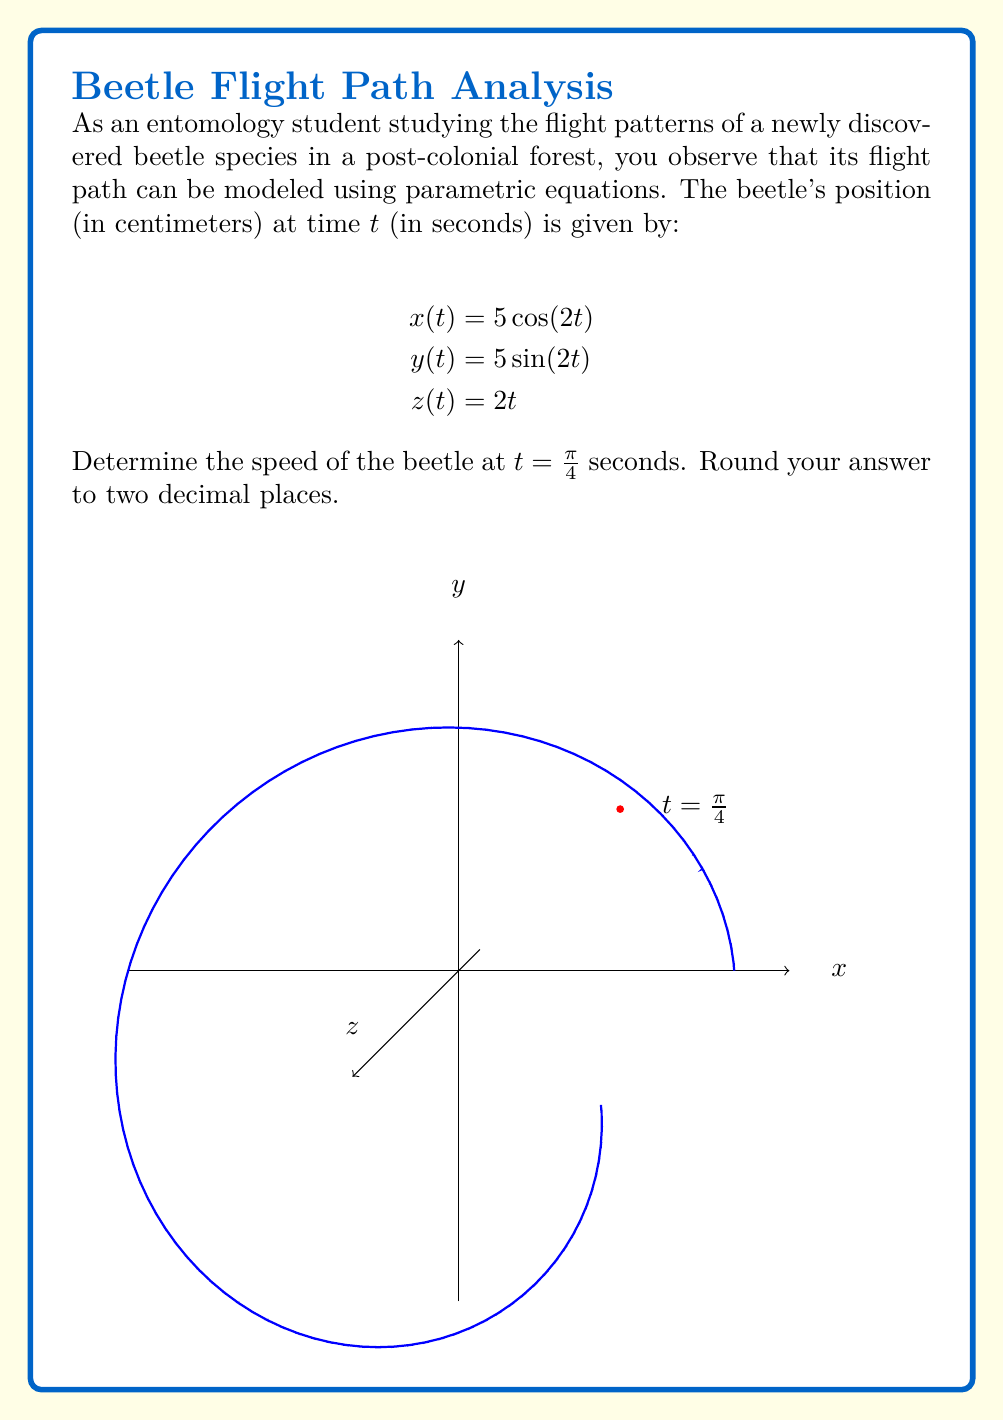Could you help me with this problem? To find the speed of the beetle, we need to calculate the magnitude of its velocity vector at t = π/4. Let's approach this step-by-step:

1) First, we need to find the velocity components by differentiating x(t), y(t), and z(t) with respect to t:

   $$\frac{dx}{dt} = -10\sin(2t)$$
   $$\frac{dy}{dt} = 10\cos(2t)$$
   $$\frac{dz}{dt} = 2$$

2) The velocity vector at any time t is:

   $$\vec{v}(t) = \left(-10\sin(2t), 10\cos(2t), 2\right)$$

3) The speed is the magnitude of the velocity vector:

   $$\text{speed} = \sqrt{\left(\frac{dx}{dt}\right)^2 + \left(\frac{dy}{dt}\right)^2 + \left(\frac{dz}{dt}\right)^2}$$

4) Substituting t = π/4 into our velocity components:

   $$\frac{dx}{dt}\bigg|_{t=\pi/4} = -10\sin(\pi/2) = -10$$
   $$\frac{dy}{dt}\bigg|_{t=\pi/4} = 10\cos(\pi/2) = 0$$
   $$\frac{dz}{dt}\bigg|_{t=\pi/4} = 2$$

5) Now, let's calculate the speed:

   $$\text{speed} = \sqrt{(-10)^2 + 0^2 + 2^2}$$
   $$= \sqrt{100 + 0 + 4}$$
   $$= \sqrt{104}$$
   $$\approx 10.20$$ (rounded to two decimal places)

Therefore, the speed of the beetle at t = π/4 seconds is approximately 10.20 cm/s.
Answer: 10.20 cm/s 